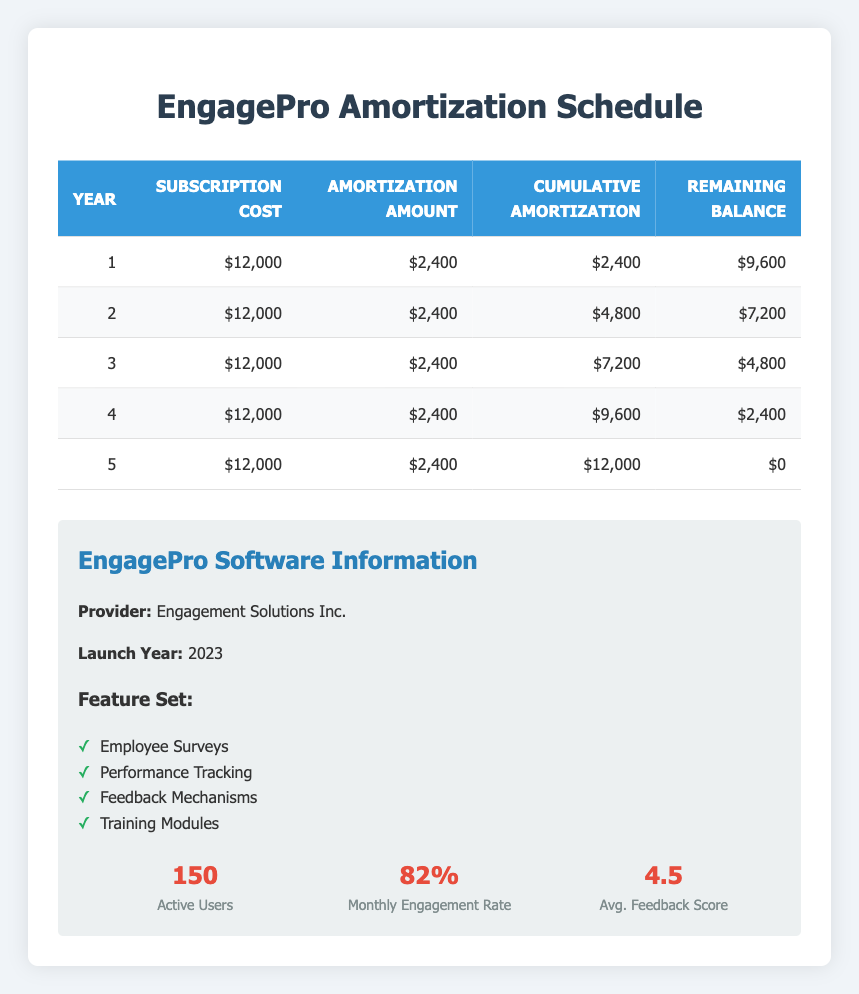What is the subscription cost for each year? The subscription cost is consistent throughout the period, being $12,000 each year, as stated in the "Subscription Cost" column of the table for all five years.
Answer: $12,000 In which year does the remaining balance reach zero? The remaining balance reaches zero at the end of year 5, as seen in the "Remaining Balance" column, where the value for year 5 is $0.
Answer: Year 5 What is the total amortization amount over the five years? The amortization amount is $2,400 each year, so for five years, the total is calculated as $2,400 multiplied by 5, which equals $12,000.
Answer: $12,000 What is the average remaining balance at the end of each year? The remaining balances for each year are: $9,600, $7,200, $4,800, $2,400, and $0. To find the average, sum these values (9,600 + 7,200 + 4,800 + 2,400 + 0) = 24,000 and divide by 5 years, resulting in an average of $4,800.
Answer: $4,800 True or False: The cumulative amortization at the end of year 3 is $6,000. From the "Cumulative Amortization" column, the cumulative amortization at the end of year 3 is $7,200. Since this is greater than $6,000, the statement is false.
Answer: False What is the cumulative amortization at the end of year 4? The cumulative amortization at the end of year 4 can be found in the "Cumulative Amortization" column for year 4, which shows $9,600.
Answer: $9,600 How much does the remaining balance decrease from year 1 to year 2? To find the decrease in remaining balance, subtract the year 2 remaining balance of $7,200 from the year 1 remaining balance of $9,600: $9,600 - $7,200 = $2,400.
Answer: $2,400 What is the total number of active users for the EngagePro software? The data indicates that the total number of active users for the EngagePro software is provided as 150, which is a single data point located in the software information section.
Answer: 150 How many years does it take for the software subscription to be fully amortized? According to the "Remaining Balance" column, the balance reaches zero at the end of year 5, indicating the subscription cost is fully amortized after 5 years.
Answer: 5 years 